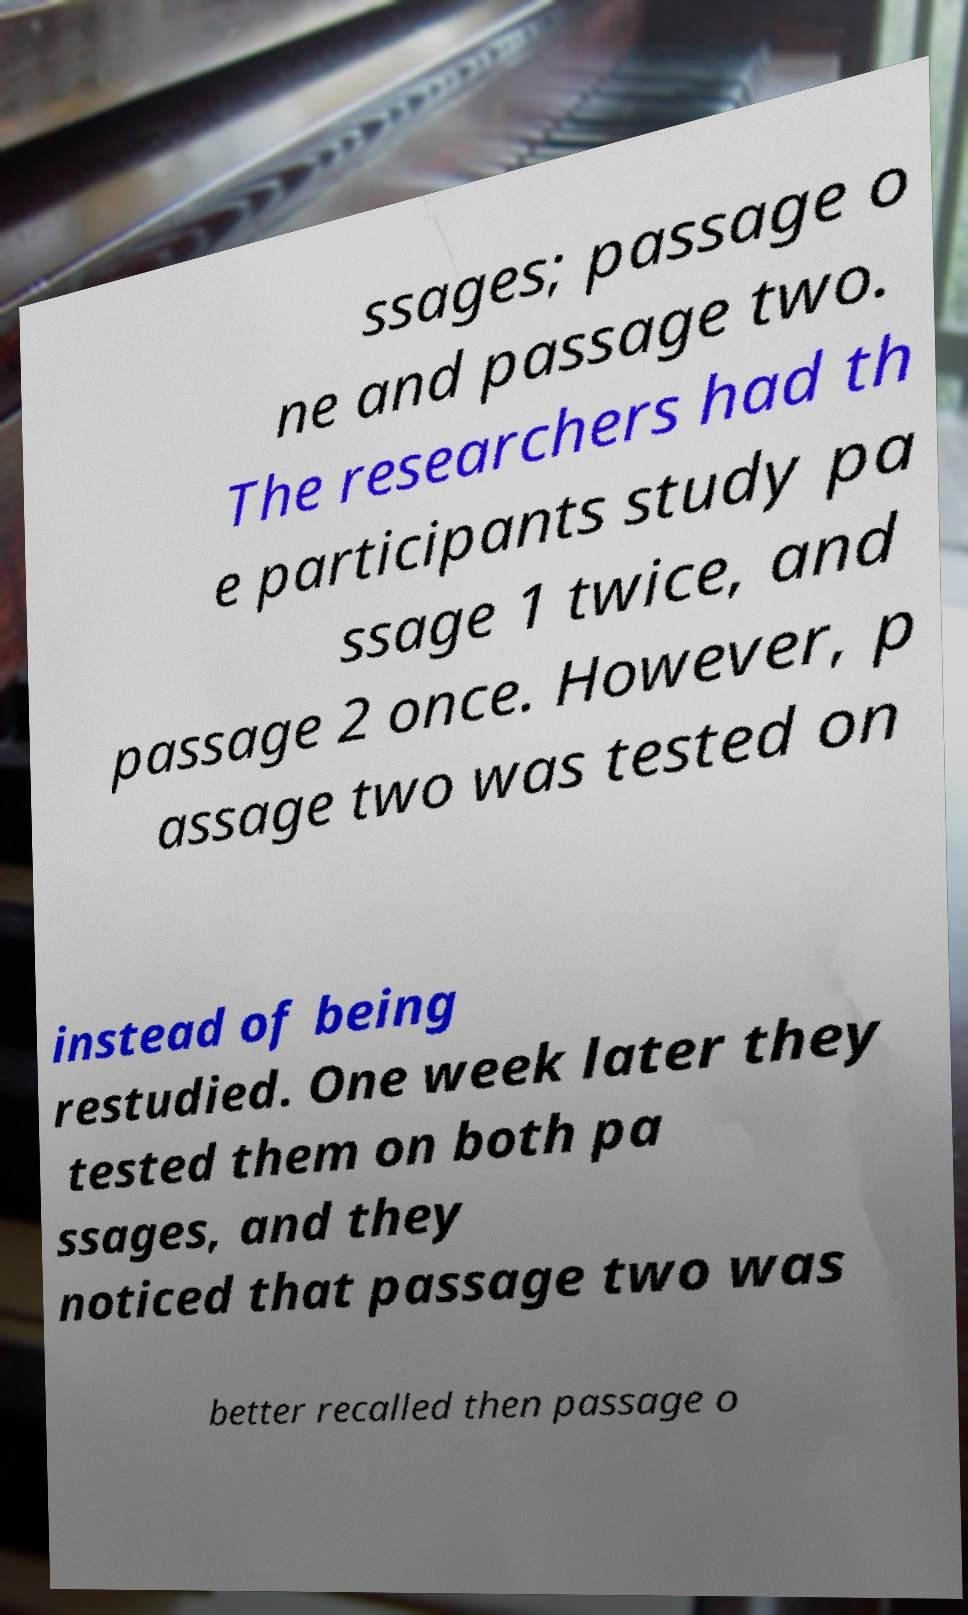What messages or text are displayed in this image? I need them in a readable, typed format. ssages; passage o ne and passage two. The researchers had th e participants study pa ssage 1 twice, and passage 2 once. However, p assage two was tested on instead of being restudied. One week later they tested them on both pa ssages, and they noticed that passage two was better recalled then passage o 